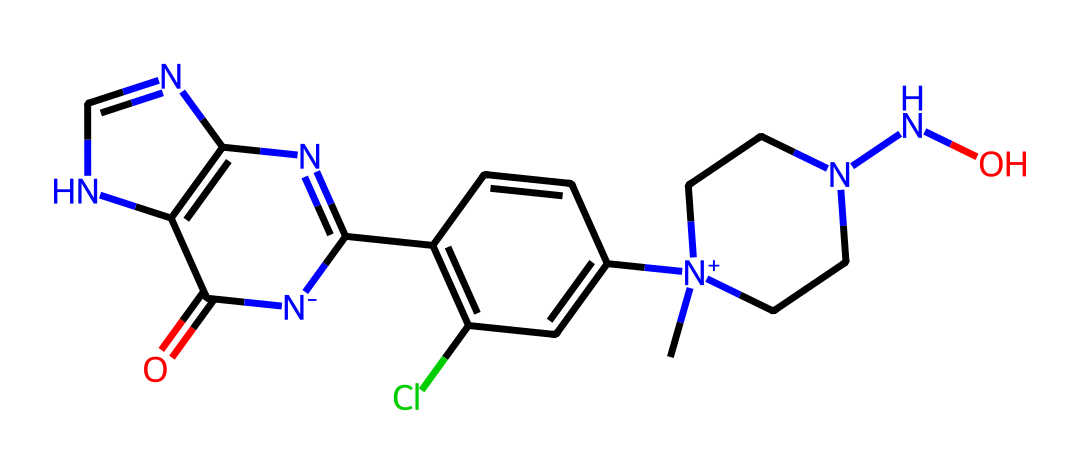What is the main functional group present in this chemical? The structure contains a nitrogen atom involved in a cationic center, which is characteristic of neonicotinoids. This functional group is a nitro group.
Answer: nitro group How many nitrogen atoms are present in this neonicotinoid structure? By examining the SMILES representation, we can identify that there are a total of 5 nitrogen atoms present in the structure, contributing to its activity.
Answer: 5 What is the number of rings present in this chemical? The structural formula shows two fused rings in the core; therefore, there are 2 rings present in the chemical.
Answer: 2 What type of bond is primarily responsible for the insecticidal activity of neonicotinoids? The structure indicates the presence of a carbon-nitrogen bond in the nitro group, crucial for the binding to nicotinic acetylcholine receptors, leading to its insecticidal activity.
Answer: carbon-nitrogen bond Does this chemical contain chlorine atoms? The provided SMILES representation indicates the presence of one chlorine atom, showing clear evidence of its halogenated nature.
Answer: 1 What overall class of chemicals does this structure belong to? The chemical structure corresponds to a class of pesticides known as neonicotinoids, which are specifically designed for insect control.
Answer: neonicotinoids 